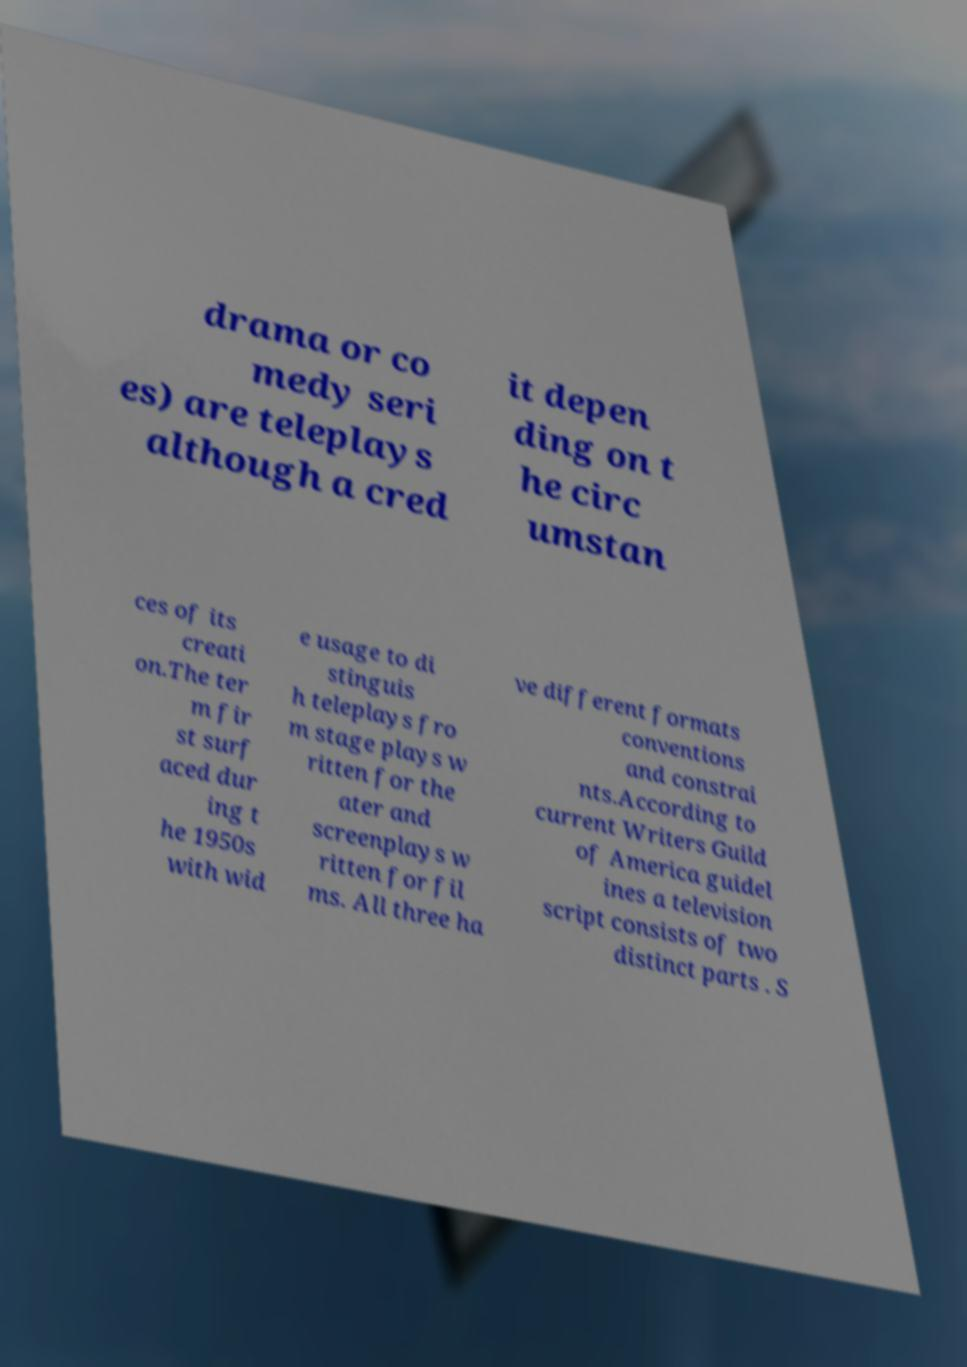I need the written content from this picture converted into text. Can you do that? drama or co medy seri es) are teleplays although a cred it depen ding on t he circ umstan ces of its creati on.The ter m fir st surf aced dur ing t he 1950s with wid e usage to di stinguis h teleplays fro m stage plays w ritten for the ater and screenplays w ritten for fil ms. All three ha ve different formats conventions and constrai nts.According to current Writers Guild of America guidel ines a television script consists of two distinct parts . S 